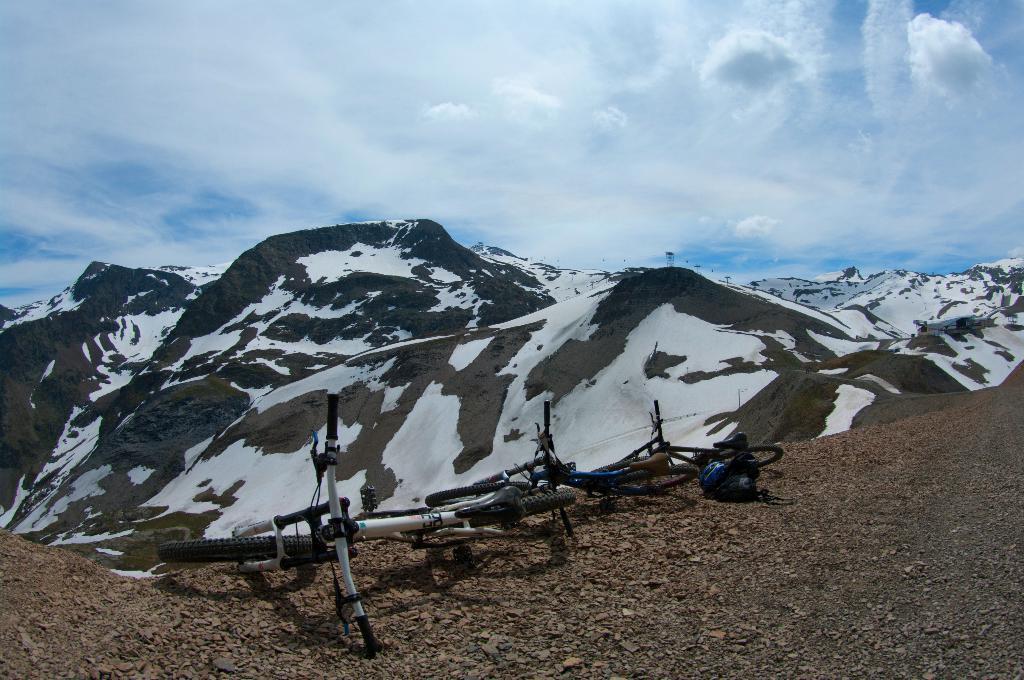Can you describe this image briefly? In this picture we can see few bicycles,in the background we can find hills and clouds. 